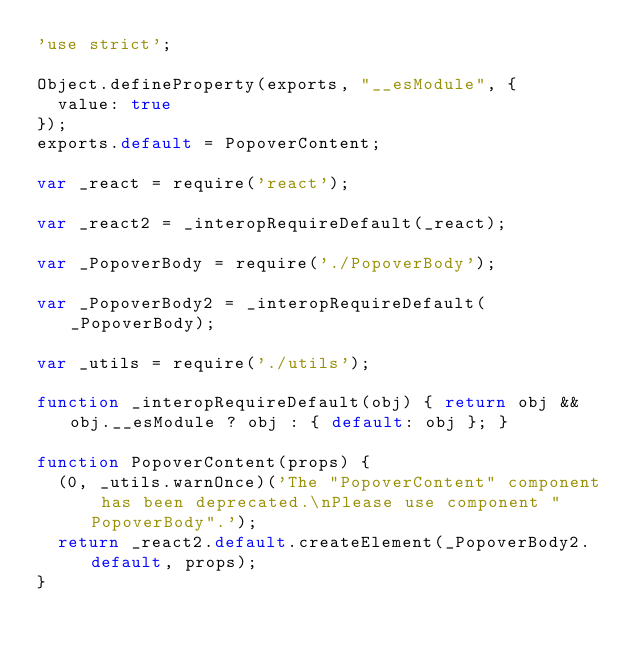Convert code to text. <code><loc_0><loc_0><loc_500><loc_500><_JavaScript_>'use strict';

Object.defineProperty(exports, "__esModule", {
  value: true
});
exports.default = PopoverContent;

var _react = require('react');

var _react2 = _interopRequireDefault(_react);

var _PopoverBody = require('./PopoverBody');

var _PopoverBody2 = _interopRequireDefault(_PopoverBody);

var _utils = require('./utils');

function _interopRequireDefault(obj) { return obj && obj.__esModule ? obj : { default: obj }; }

function PopoverContent(props) {
  (0, _utils.warnOnce)('The "PopoverContent" component has been deprecated.\nPlease use component "PopoverBody".');
  return _react2.default.createElement(_PopoverBody2.default, props);
}</code> 